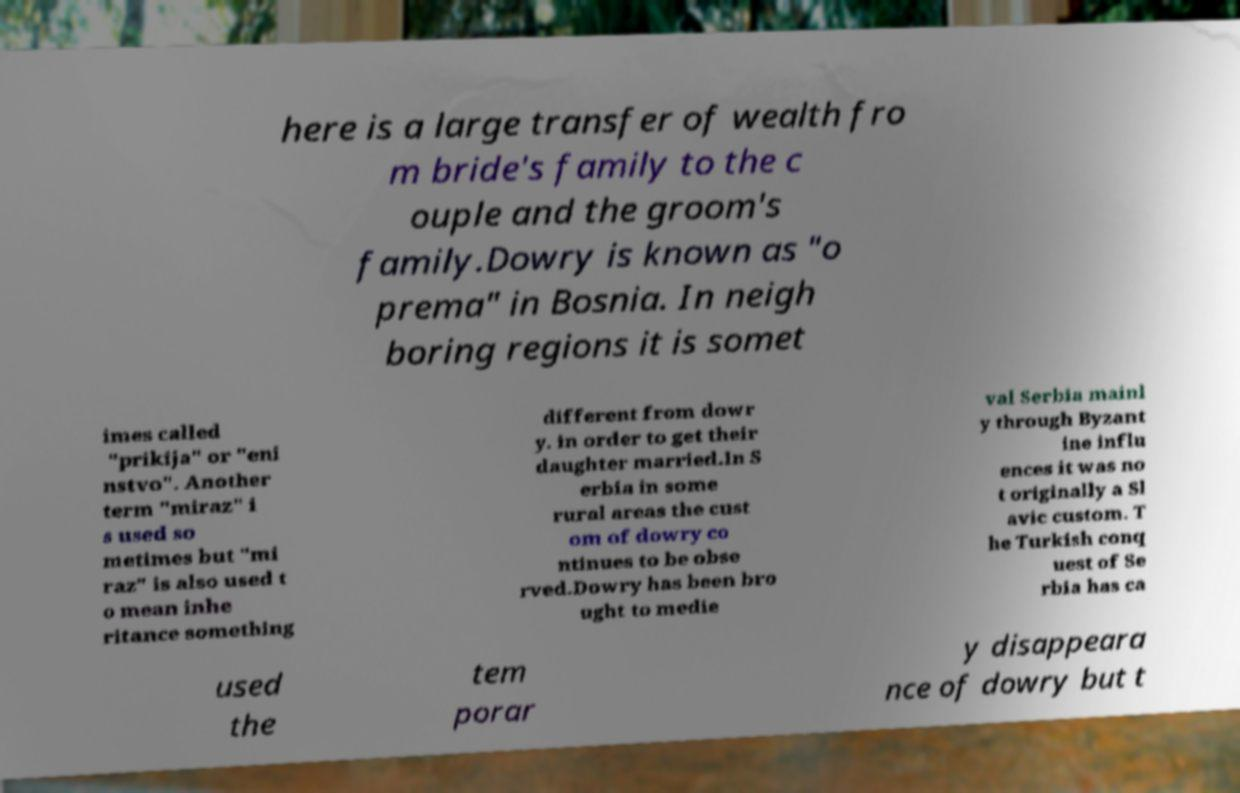Could you extract and type out the text from this image? here is a large transfer of wealth fro m bride's family to the c ouple and the groom's family.Dowry is known as "o prema" in Bosnia. In neigh boring regions it is somet imes called "prikija" or "eni nstvo". Another term "miraz" i s used so metimes but "mi raz" is also used t o mean inhe ritance something different from dowr y. in order to get their daughter married.In S erbia in some rural areas the cust om of dowry co ntinues to be obse rved.Dowry has been bro ught to medie val Serbia mainl y through Byzant ine influ ences it was no t originally a Sl avic custom. T he Turkish conq uest of Se rbia has ca used the tem porar y disappeara nce of dowry but t 